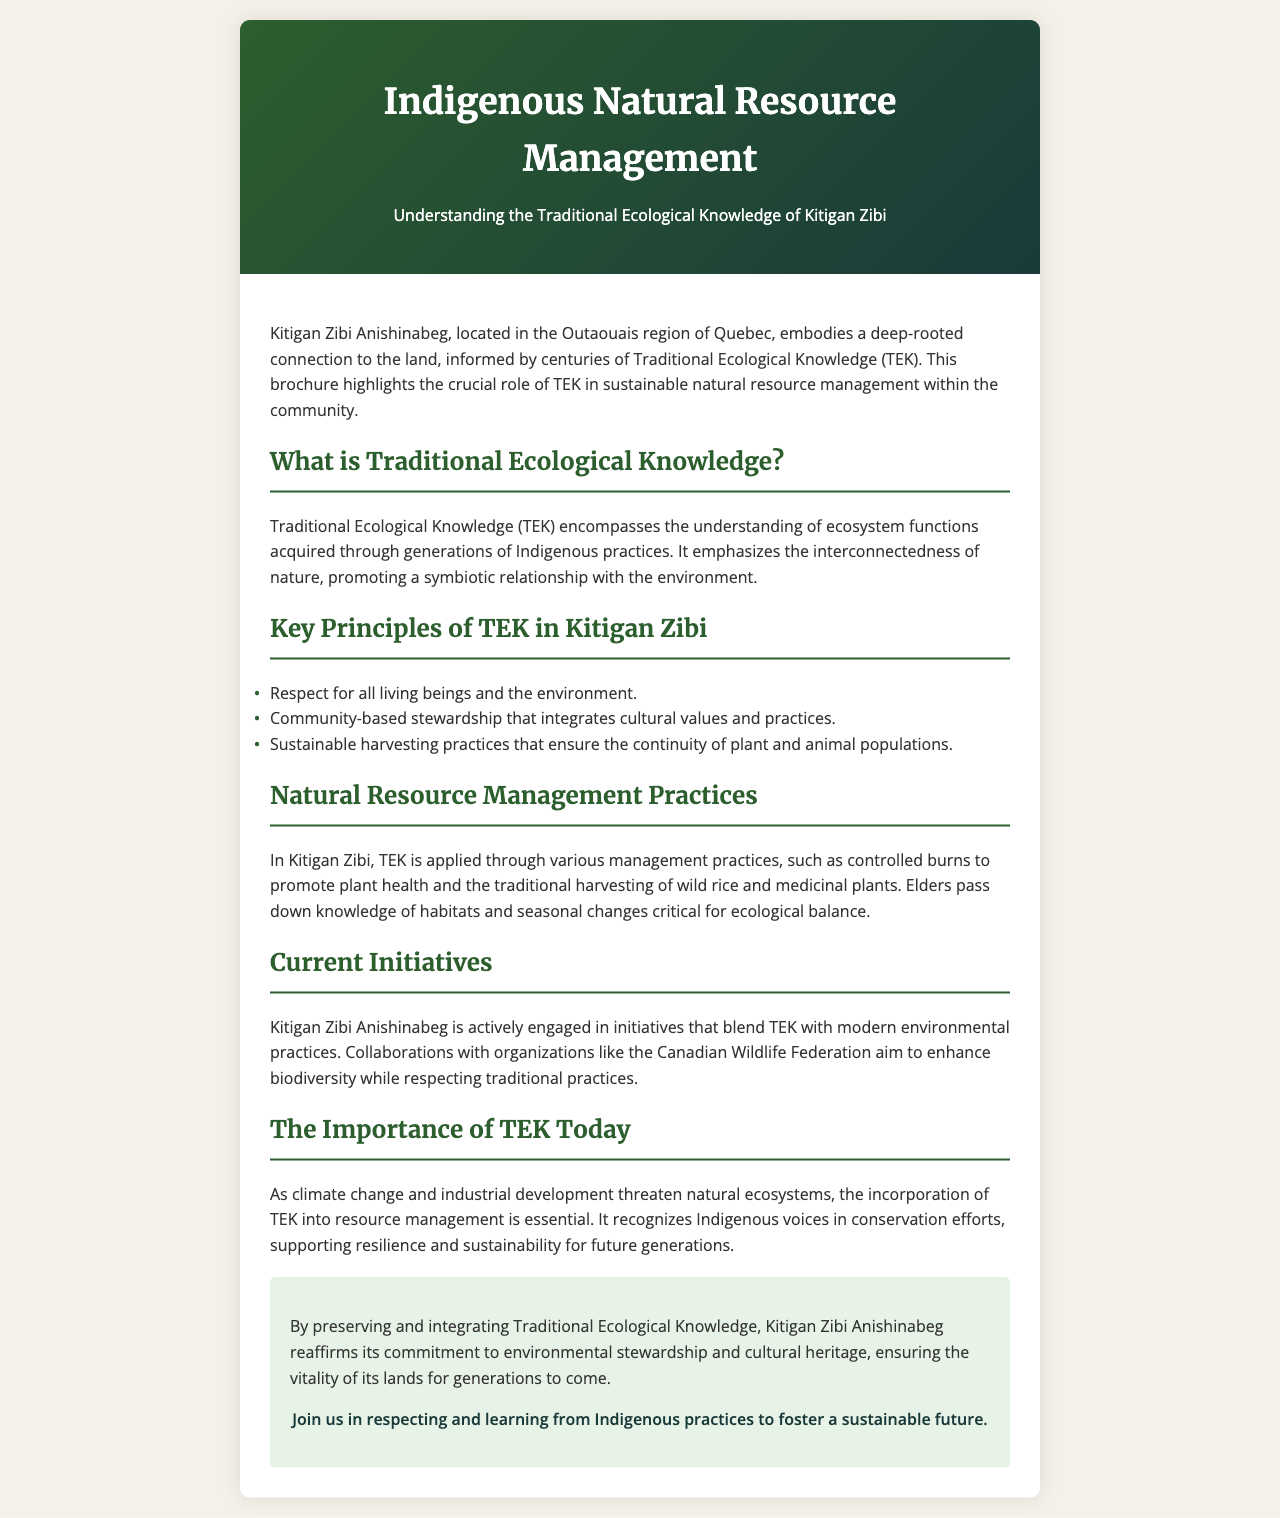What is the title of the brochure? The title of the brochure is found at the top section of the document.
Answer: Indigenous Natural Resource Management What does TEK stand for? The abbreviation TEK is defined in the section describing Traditional Ecological Knowledge.
Answer: Traditional Ecological Knowledge Where is Kitigan Zibi located? The location of Kitigan Zibi is stated in the introductory paragraph of the brochure.
Answer: Outaouais region of Quebec What is the first key principle of TEK in Kitigan Zibi? The key principles are listed in the section titled "Key Principles of TEK in Kitigan Zibi."
Answer: Respect for all living beings and the environment What type of management practices does Kitigan Zibi apply? The section discussing management practices specifies the type used in the community.
Answer: Controlled burns What initiative is Kitigan Zibi engaged in that combines TEK with modern practices? The current initiatives section mentions specific collaborations focused on resource management.
Answer: Canadian Wildlife Federation Why is TEK important today? The importance of TEK is explained in a specific section discussing contemporary relevance.
Answer: Supports resilience and sustainability What is the main commitment of Kitigan Zibi Anishinabeg regarding the environment? The conclusion outlines the commitments made by the community toward their land and heritage.
Answer: Environmental stewardship and cultural heritage 